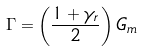Convert formula to latex. <formula><loc_0><loc_0><loc_500><loc_500>\Gamma = \left ( \frac { 1 + \gamma _ { r } } 2 \right ) G _ { m } \text { }</formula> 